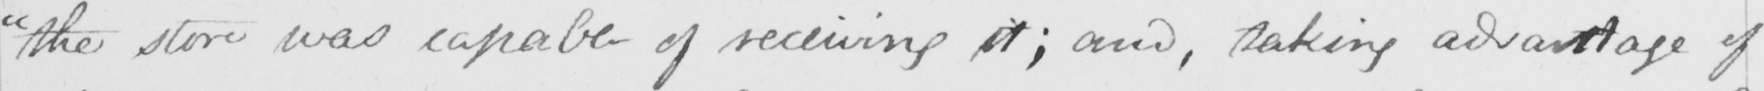Please transcribe the handwritten text in this image. " the store was capable of receiving it ; and , taking advantage of 